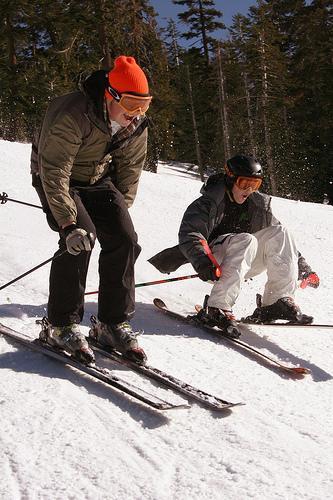How many people are there?
Give a very brief answer. 2. 